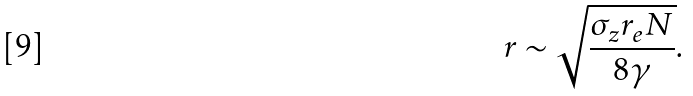<formula> <loc_0><loc_0><loc_500><loc_500>r \sim \sqrt { \frac { \sigma _ { z } r _ { e } N } { 8 \gamma } } .</formula> 